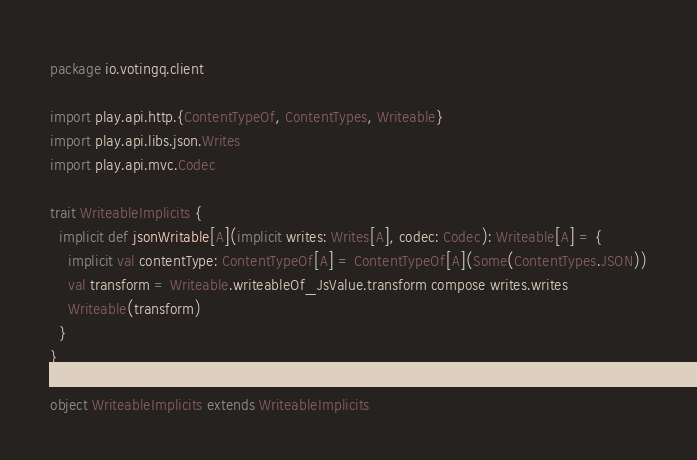<code> <loc_0><loc_0><loc_500><loc_500><_Scala_>package io.votingq.client

import play.api.http.{ContentTypeOf, ContentTypes, Writeable}
import play.api.libs.json.Writes
import play.api.mvc.Codec

trait WriteableImplicits {
  implicit def jsonWritable[A](implicit writes: Writes[A], codec: Codec): Writeable[A] = {
    implicit val contentType: ContentTypeOf[A] = ContentTypeOf[A](Some(ContentTypes.JSON))
    val transform = Writeable.writeableOf_JsValue.transform compose writes.writes
    Writeable(transform)
  }
}

object WriteableImplicits extends WriteableImplicits
</code> 